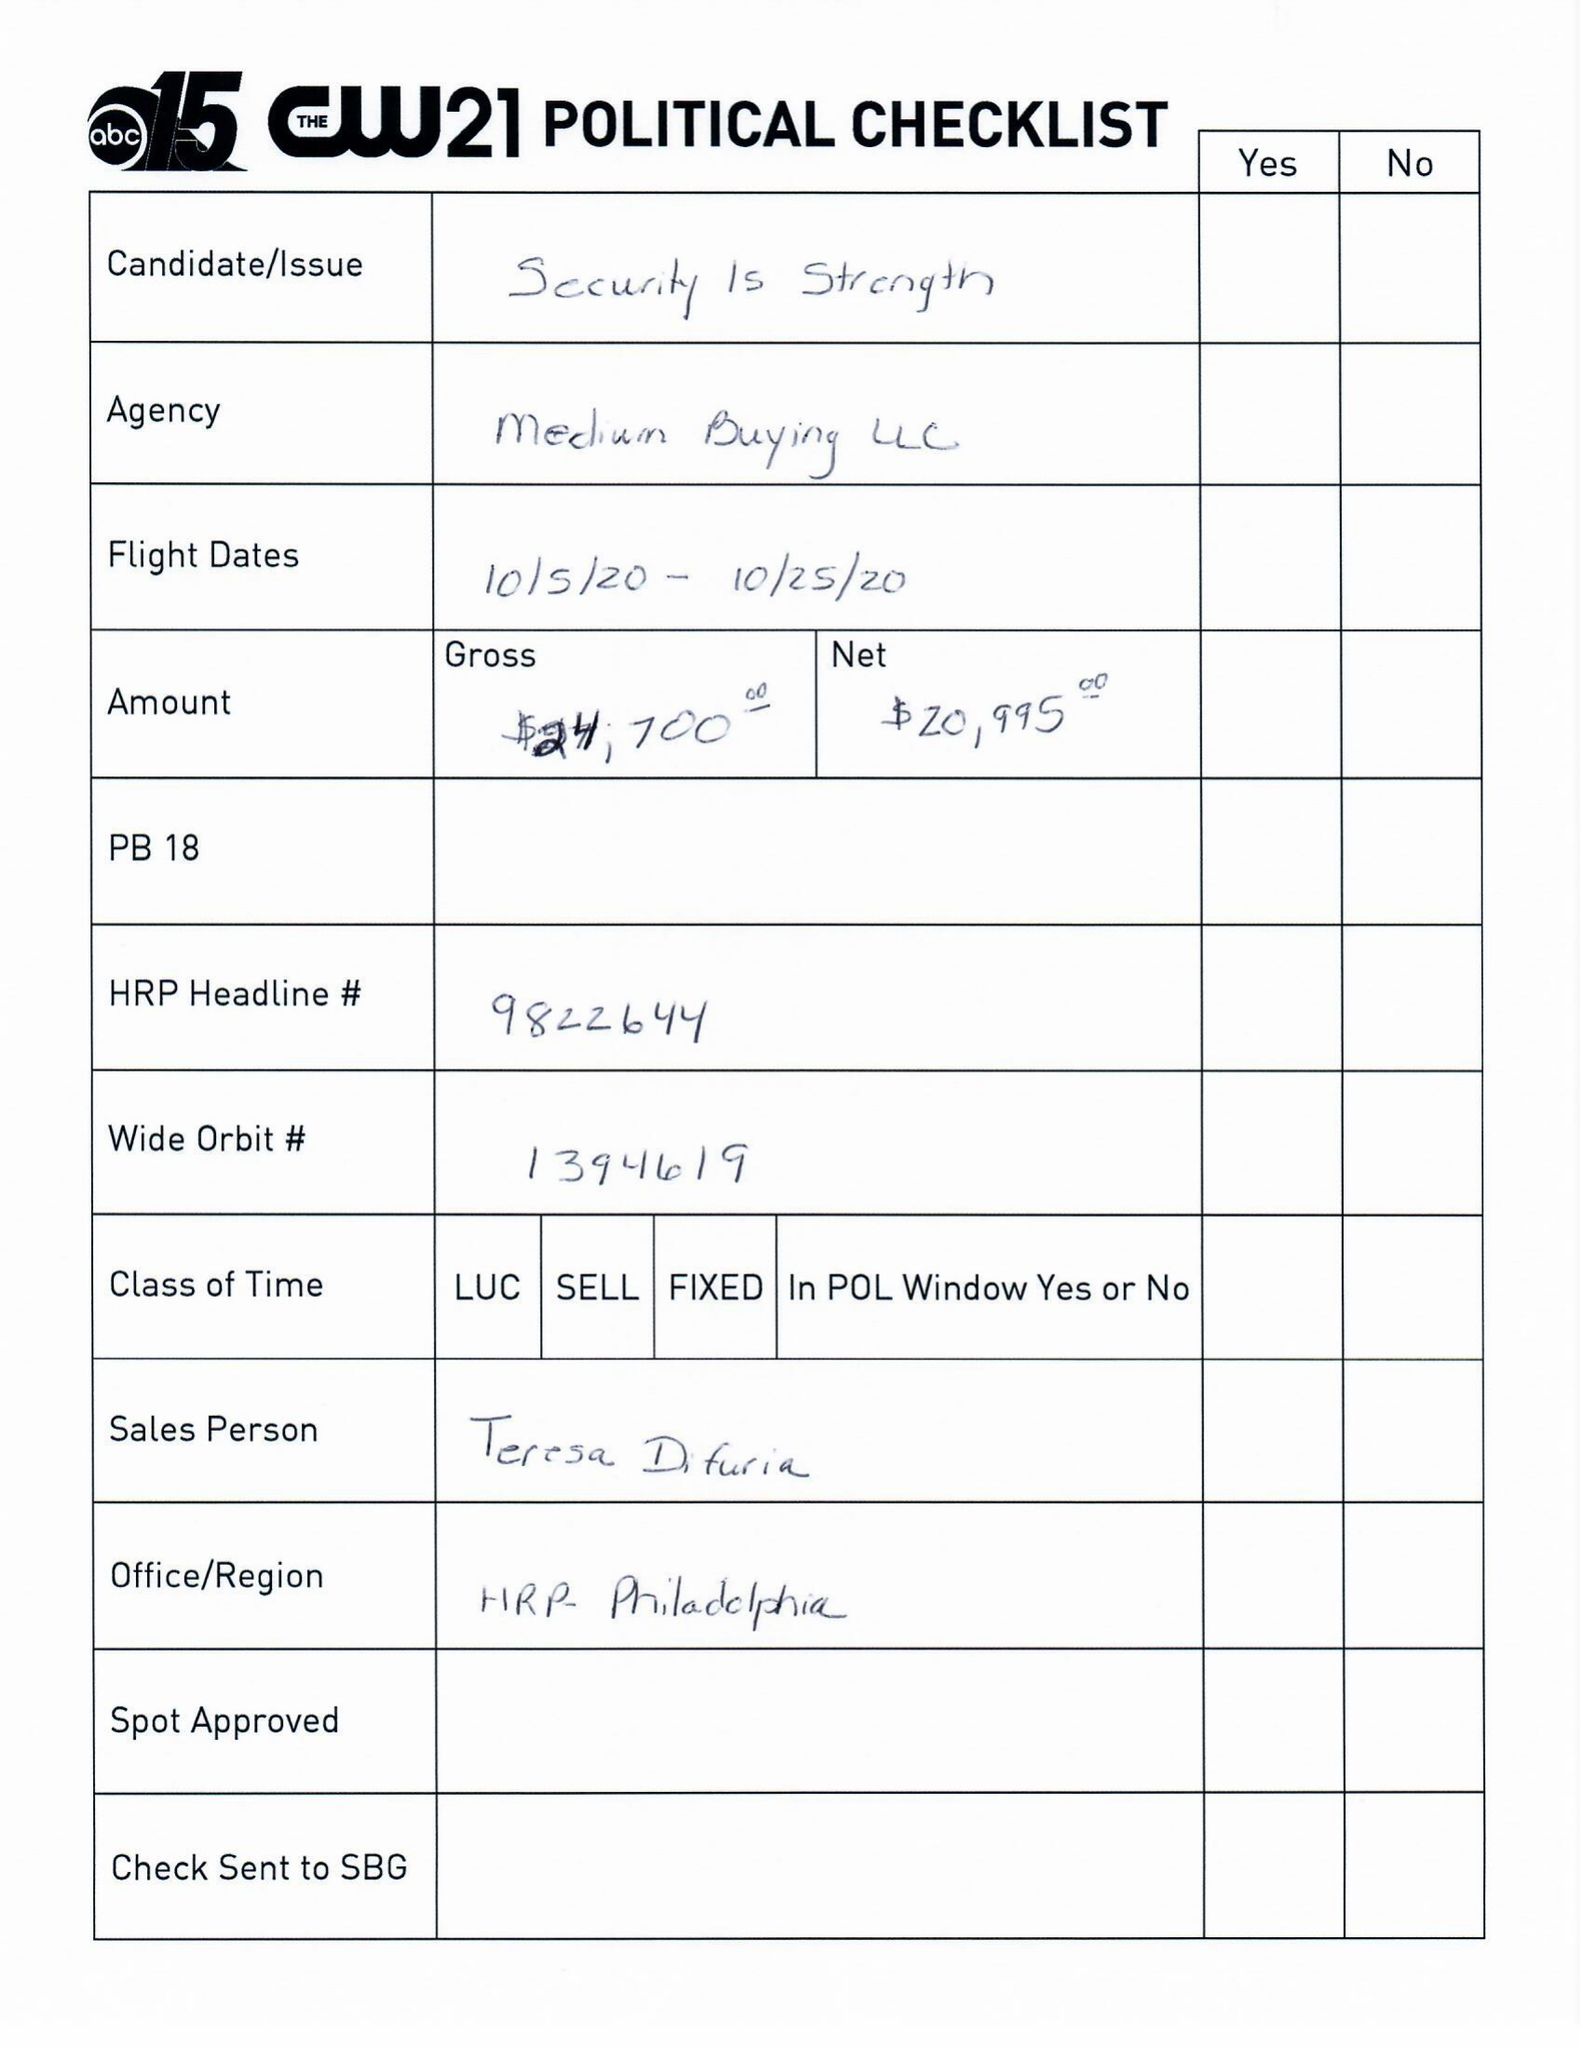What is the value for the contract_num?
Answer the question using a single word or phrase. 1394619 